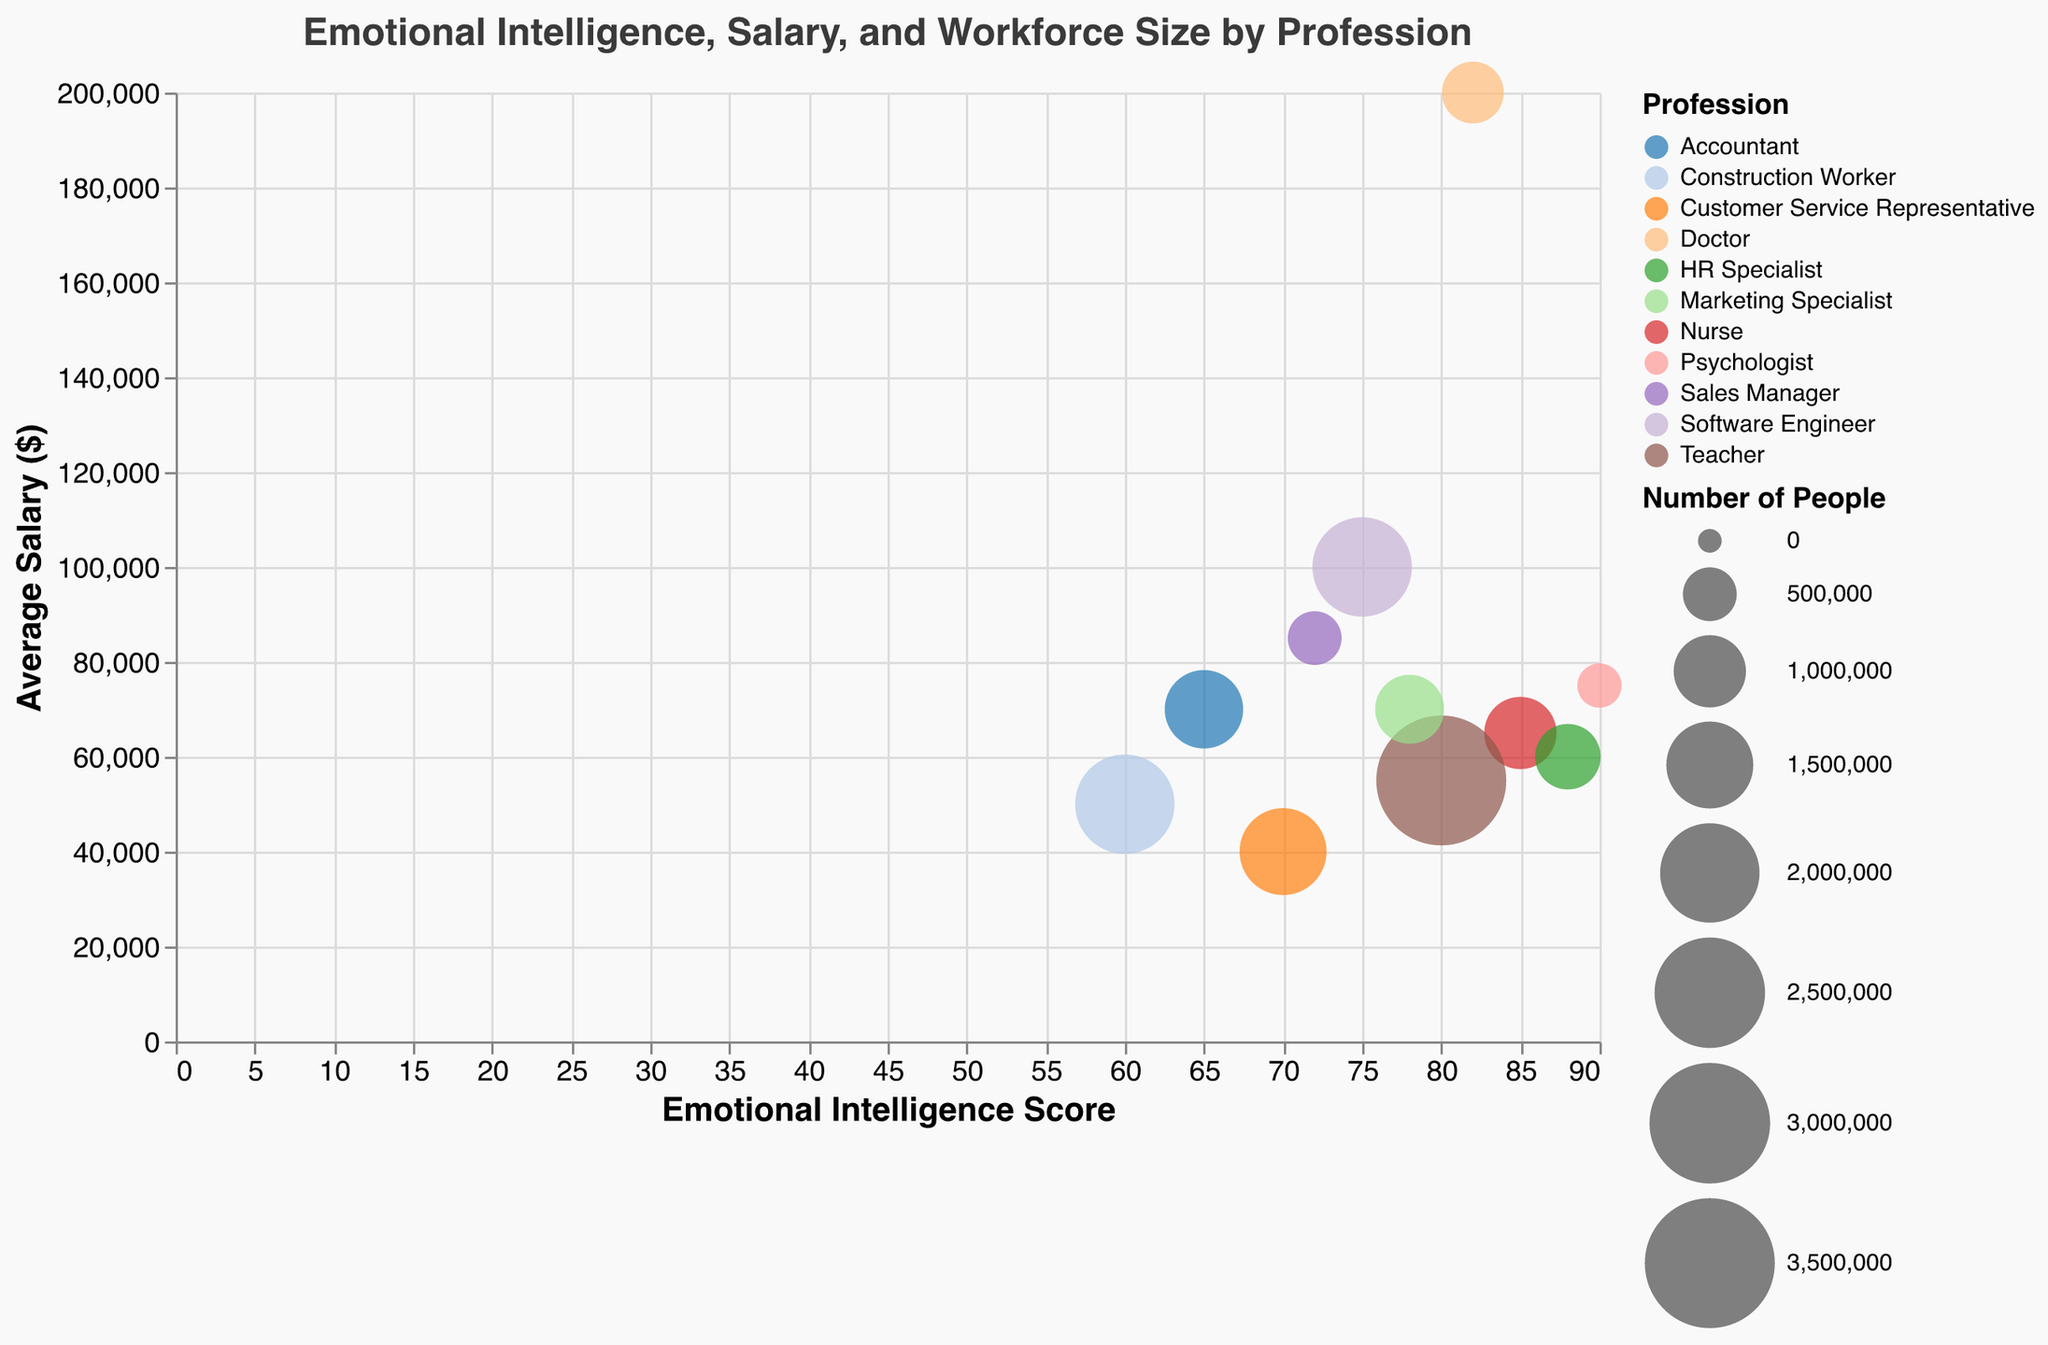What is the highest Emotional Intelligence Score visible in this figure? The highest Emotional Intelligence Score is the maximum x-axis value in the plot. By checking the x-values, the maximum score we find is 90, which corresponds to the Psychologist profession.
Answer: 90 Which profession has the largest number of people? The size of the bubbles represents the number of people. Taking a look at the largest bubble shows that the Teacher profession has the largest number of people at 3,500,000.
Answer: Teacher What's the difference in Emotional Intelligence Scores between Doctors and Nurses? The Emotional Intelligence Score for Doctors is 82, and for Nurses, it's 85. Subtracting these gives 85 - 82, which results in a difference of 3.
Answer: 3 Which profession has the highest average salary? To find the highest average salary, we look at the y-axis values. The highest y-value corresponds to the Doctor profession with an average salary of $200,000.
Answer: Doctor What's the sum of the number of people in the HR Specialist and Construction Worker professions? The number of people in the HR Specialist profession is 800,000, and in Construction Worker, it's 2,000,000. Adding these together gives 800,000 + 2,000,000 = 2,800,000.
Answer: 2,800,000 Out of the professions with an Emotional Intelligence Score greater than 80, which one has the highest average salary? First identify professions with an Emotional Intelligence Score above 80 (Nurse, Psychologist, HR Specialist, Doctor). Among these, check the y-values. The highest average salary is for Doctors at $200,000.
Answer: Doctor Compare the average salaries of Software Engineers and Marketing Specialists. Which one is higher, and by how much? Software Engineers have an average salary of $100,000, while Marketing Specialists have $70,000. The difference is $100,000 - $70,000 = $30,000.
Answer: Software Engineers, by $30,000 What is the average Emotional Intelligence Score across all professions shown in the chart? To calculate the average, sum up all Emotional Intelligence Scores: 85+80+75+90+70+72+88+65+60+78+82 = 845. There are 11 professions, so the average score is 845 / 11 = approximately 76.82.
Answer: Approximately 76.82 